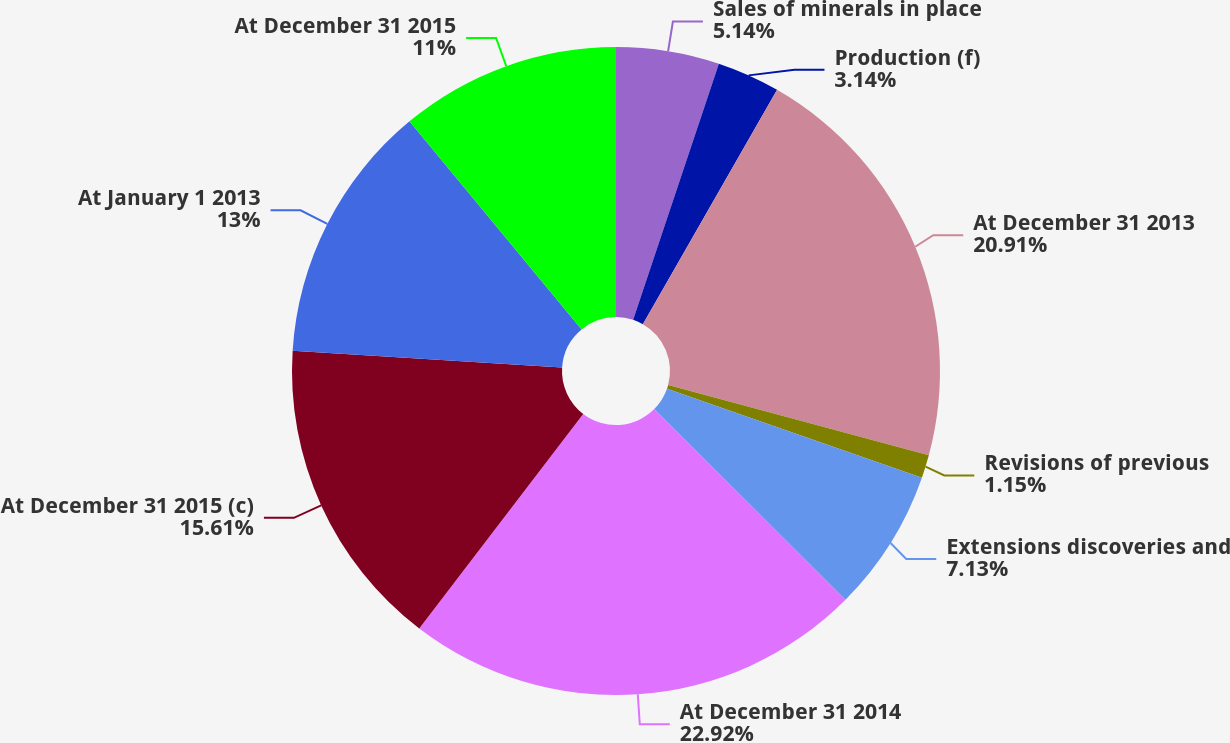Convert chart. <chart><loc_0><loc_0><loc_500><loc_500><pie_chart><fcel>Sales of minerals in place<fcel>Production (f)<fcel>At December 31 2013<fcel>Revisions of previous<fcel>Extensions discoveries and<fcel>At December 31 2014<fcel>At December 31 2015 (c)<fcel>At January 1 2013<fcel>At December 31 2015<nl><fcel>5.14%<fcel>3.14%<fcel>20.91%<fcel>1.15%<fcel>7.13%<fcel>22.91%<fcel>15.61%<fcel>13.0%<fcel>11.0%<nl></chart> 